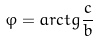Convert formula to latex. <formula><loc_0><loc_0><loc_500><loc_500>\varphi = a r c t g \frac { c } { b }</formula> 